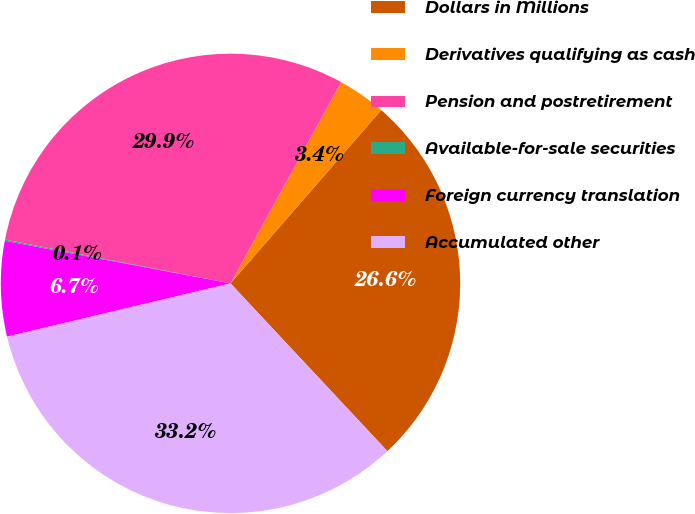Convert chart. <chart><loc_0><loc_0><loc_500><loc_500><pie_chart><fcel>Dollars in Millions<fcel>Derivatives qualifying as cash<fcel>Pension and postretirement<fcel>Available-for-sale securities<fcel>Foreign currency translation<fcel>Accumulated other<nl><fcel>26.64%<fcel>3.39%<fcel>29.94%<fcel>0.09%<fcel>6.69%<fcel>33.24%<nl></chart> 